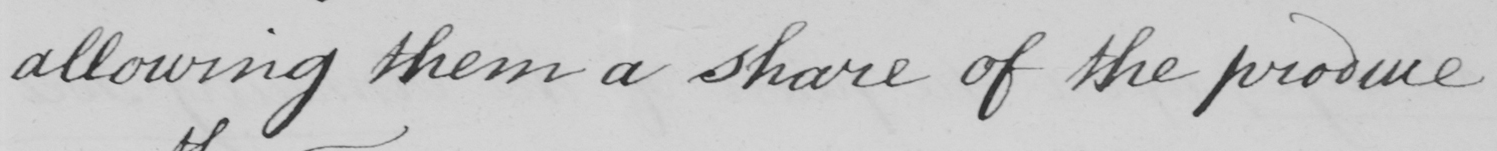Can you read and transcribe this handwriting? allowing them a share of the produce . 